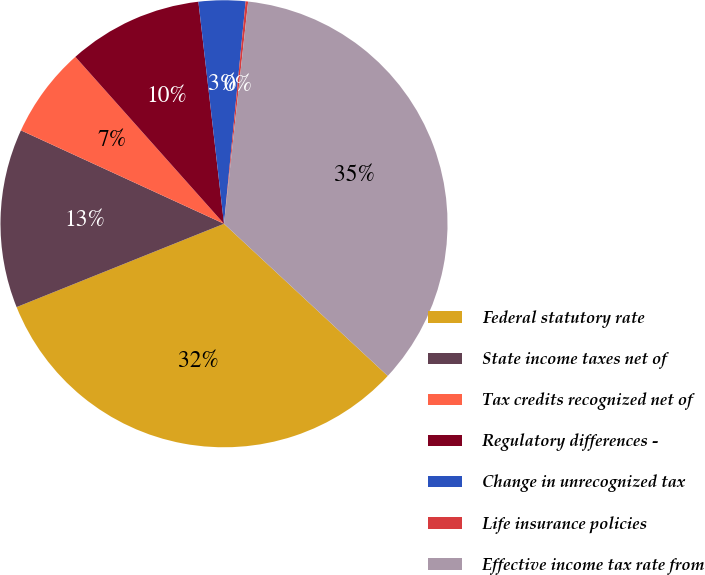Convert chart. <chart><loc_0><loc_0><loc_500><loc_500><pie_chart><fcel>Federal statutory rate<fcel>State income taxes net of<fcel>Tax credits recognized net of<fcel>Regulatory differences -<fcel>Change in unrecognized tax<fcel>Life insurance policies<fcel>Effective income tax rate from<nl><fcel>32.0%<fcel>12.94%<fcel>6.56%<fcel>9.75%<fcel>3.37%<fcel>0.18%<fcel>35.19%<nl></chart> 